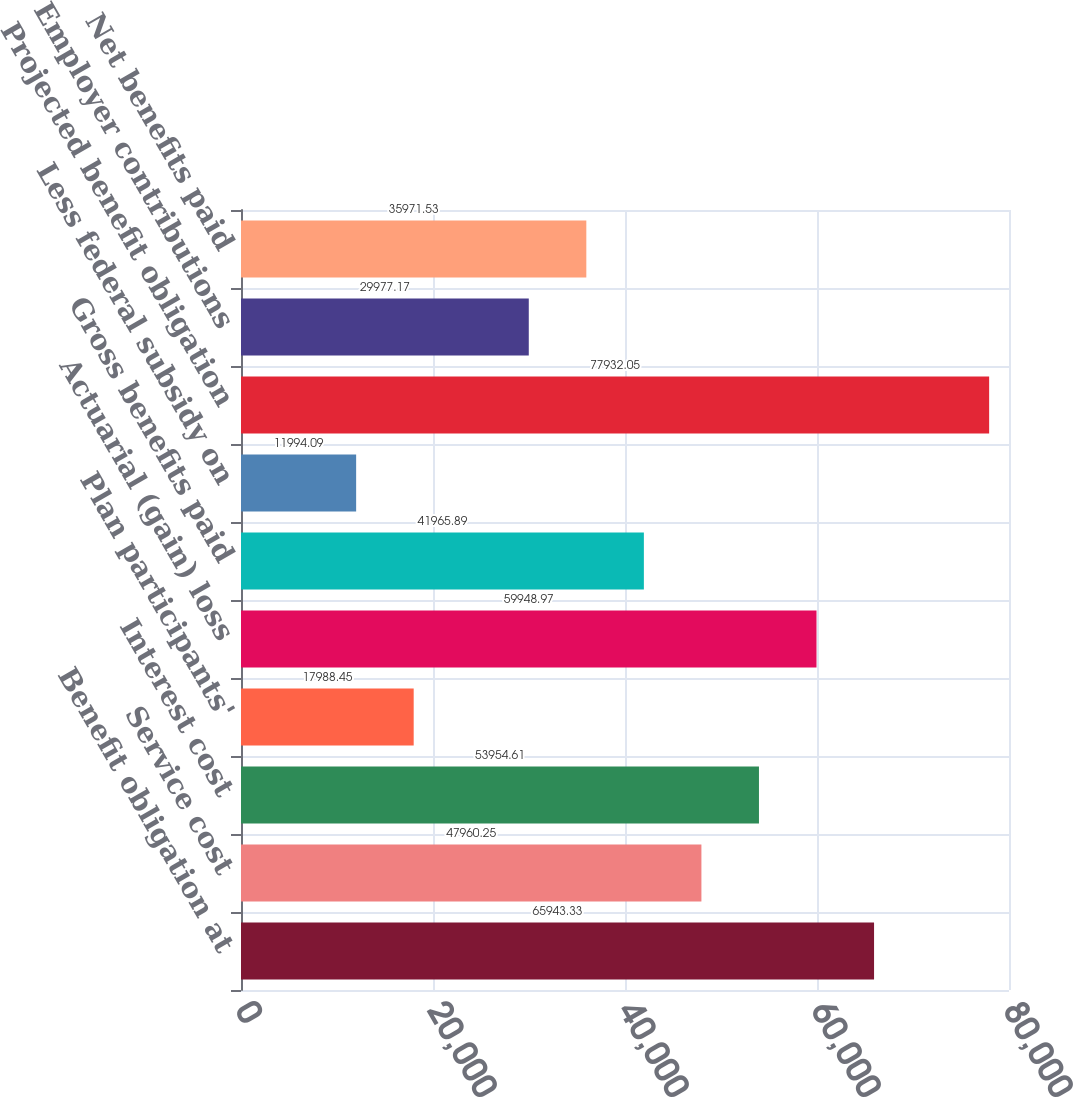Convert chart to OTSL. <chart><loc_0><loc_0><loc_500><loc_500><bar_chart><fcel>Benefit obligation at<fcel>Service cost<fcel>Interest cost<fcel>Plan participants'<fcel>Actuarial (gain) loss<fcel>Gross benefits paid<fcel>Less federal subsidy on<fcel>Projected benefit obligation<fcel>Employer contributions<fcel>Net benefits paid<nl><fcel>65943.3<fcel>47960.2<fcel>53954.6<fcel>17988.5<fcel>59949<fcel>41965.9<fcel>11994.1<fcel>77932.1<fcel>29977.2<fcel>35971.5<nl></chart> 